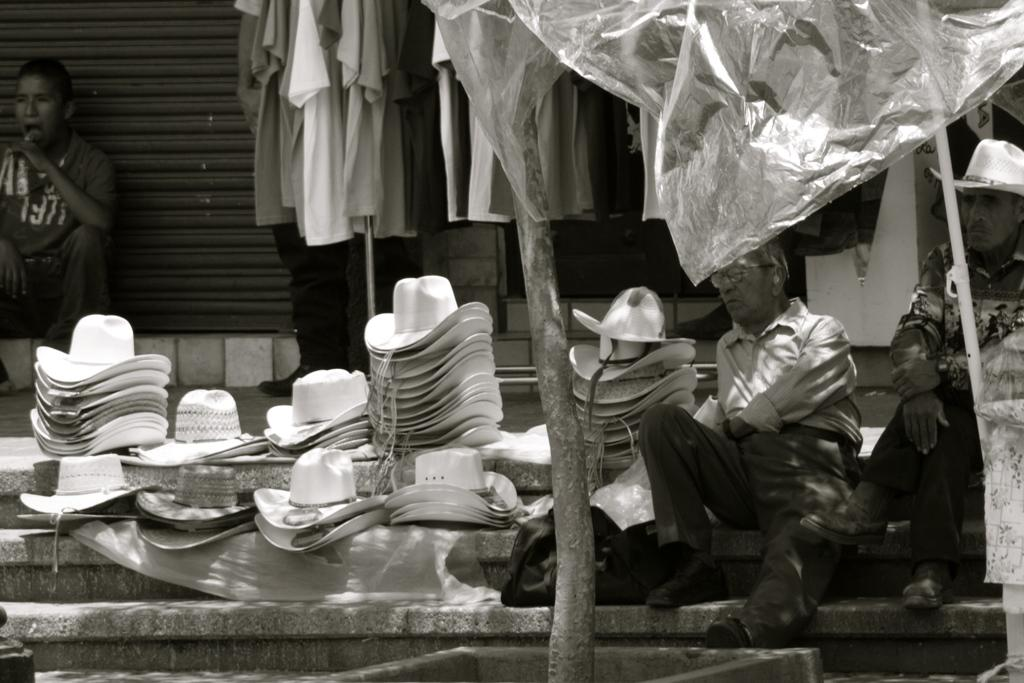What is the color scheme of the image? The image is black and white. What are the persons in the image doing? The persons are sitting on stairs in the image. What type of headwear can be seen in the image? There are hats visible in the image. What type of establishment is present in the image? There is a store in the image. What type of material is used for covering items in the image? Polythene covers are present in the image. How many steps does the screw have in the image? There is no screw present in the image, so it is not possible to determine the number of steps it has. 